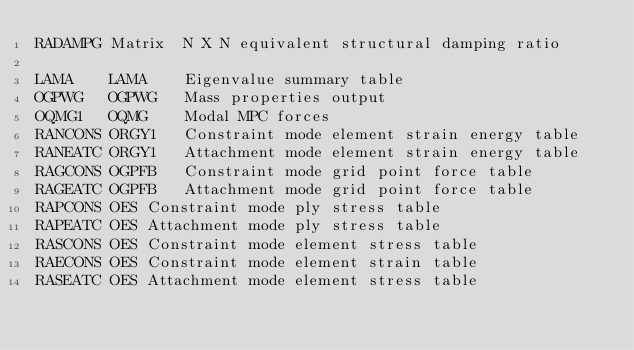Convert code to text. <code><loc_0><loc_0><loc_500><loc_500><_Python_>RADAMPG	Matrix	N X N equivalent structural damping ratio

LAMA	LAMA	Eigenvalue summary table
OGPWG	OGPWG	Mass properties output
OQMG1	OQMG	Modal MPC forces
RANCONS	ORGY1	Constraint mode element strain energy table
RANEATC	ORGY1	Attachment mode element strain energy table
RAGCONS	OGPFB	Constraint mode grid point force table
RAGEATC	OGPFB	Attachment mode grid point force table
RAPCONS	OES	Constraint mode ply stress table
RAPEATC	OES	Attachment mode ply stress table
RASCONS	OES	Constraint mode element stress table
RAECONS	OES	Constraint mode element strain table
RASEATC	OES	Attachment mode element stress table</code> 